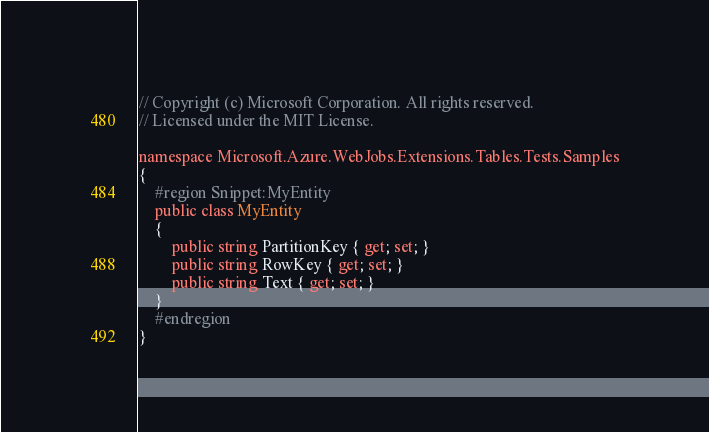<code> <loc_0><loc_0><loc_500><loc_500><_C#_>// Copyright (c) Microsoft Corporation. All rights reserved.
// Licensed under the MIT License.

namespace Microsoft.Azure.WebJobs.Extensions.Tables.Tests.Samples
{
    #region Snippet:MyEntity
    public class MyEntity
    {
        public string PartitionKey { get; set; }
        public string RowKey { get; set; }
        public string Text { get; set; }
    }
    #endregion
}</code> 